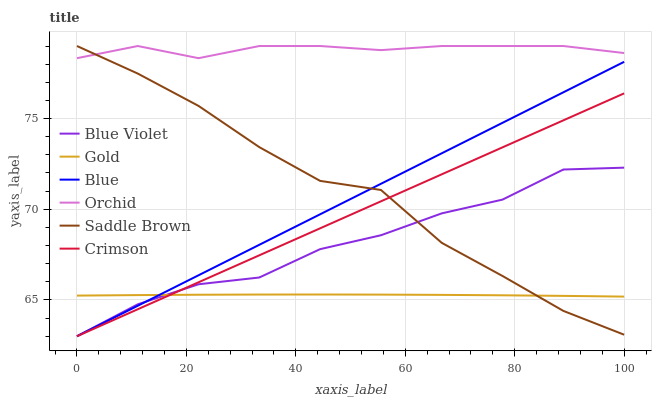Does Gold have the minimum area under the curve?
Answer yes or no. Yes. Does Orchid have the maximum area under the curve?
Answer yes or no. Yes. Does Crimson have the minimum area under the curve?
Answer yes or no. No. Does Crimson have the maximum area under the curve?
Answer yes or no. No. Is Blue the smoothest?
Answer yes or no. Yes. Is Saddle Brown the roughest?
Answer yes or no. Yes. Is Gold the smoothest?
Answer yes or no. No. Is Gold the roughest?
Answer yes or no. No. Does Blue have the lowest value?
Answer yes or no. Yes. Does Gold have the lowest value?
Answer yes or no. No. Does Orchid have the highest value?
Answer yes or no. Yes. Does Crimson have the highest value?
Answer yes or no. No. Is Crimson less than Orchid?
Answer yes or no. Yes. Is Orchid greater than Blue Violet?
Answer yes or no. Yes. Does Gold intersect Blue Violet?
Answer yes or no. Yes. Is Gold less than Blue Violet?
Answer yes or no. No. Is Gold greater than Blue Violet?
Answer yes or no. No. Does Crimson intersect Orchid?
Answer yes or no. No. 